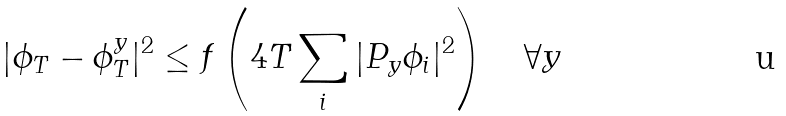Convert formula to latex. <formula><loc_0><loc_0><loc_500><loc_500>| \phi _ { T } - \phi _ { T } ^ { y } | ^ { 2 } \leq f \left ( 4 T \sum _ { i } | P _ { y } \phi _ { i } | ^ { 2 } \right ) \quad \forall y</formula> 